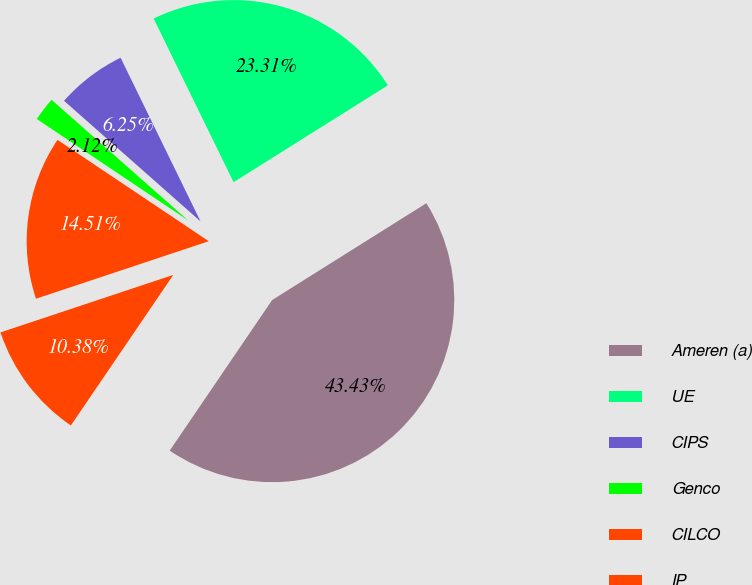Convert chart. <chart><loc_0><loc_0><loc_500><loc_500><pie_chart><fcel>Ameren (a)<fcel>UE<fcel>CIPS<fcel>Genco<fcel>CILCO<fcel>IP<nl><fcel>43.43%<fcel>23.31%<fcel>6.25%<fcel>2.12%<fcel>14.51%<fcel>10.38%<nl></chart> 